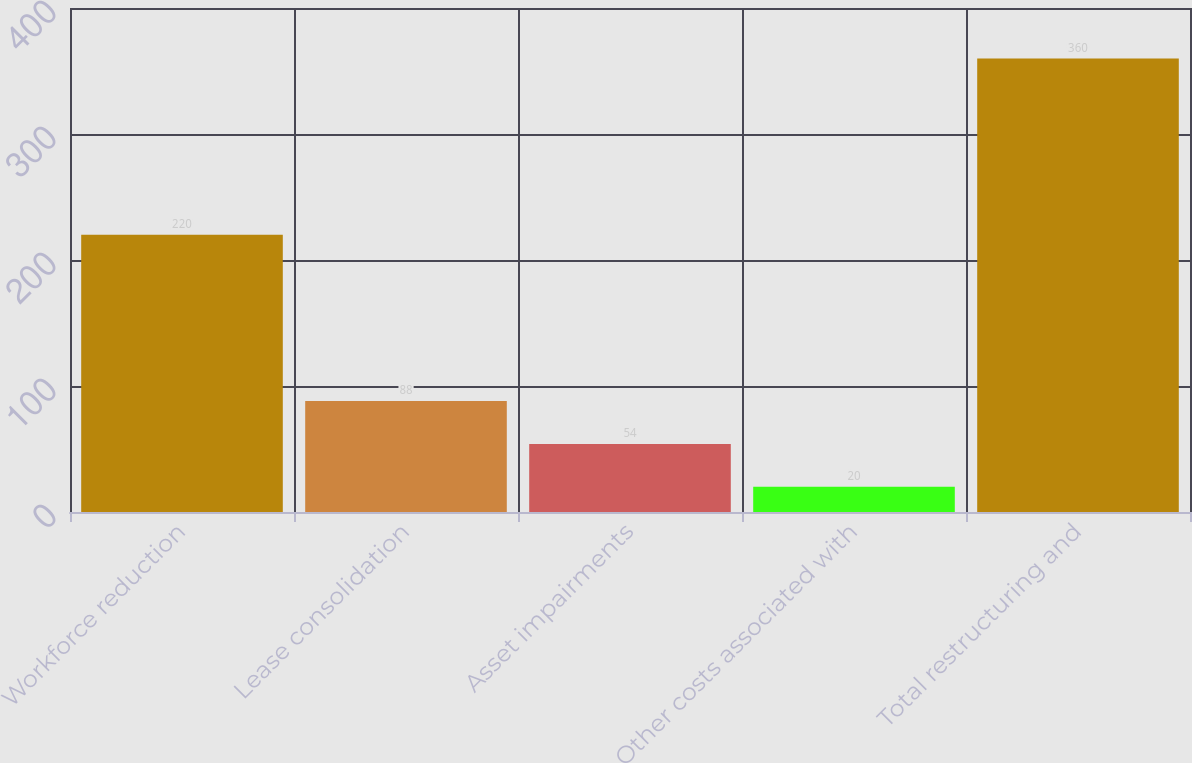Convert chart to OTSL. <chart><loc_0><loc_0><loc_500><loc_500><bar_chart><fcel>Workforce reduction<fcel>Lease consolidation<fcel>Asset impairments<fcel>Other costs associated with<fcel>Total restructuring and<nl><fcel>220<fcel>88<fcel>54<fcel>20<fcel>360<nl></chart> 